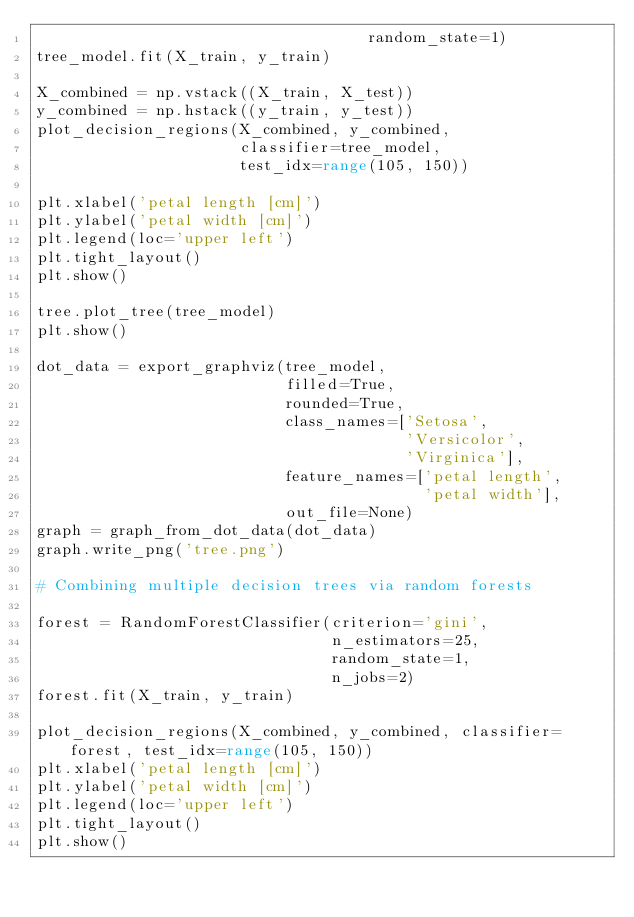Convert code to text. <code><loc_0><loc_0><loc_500><loc_500><_Python_>                                    random_state=1)
tree_model.fit(X_train, y_train)

X_combined = np.vstack((X_train, X_test))
y_combined = np.hstack((y_train, y_test))
plot_decision_regions(X_combined, y_combined, 
                      classifier=tree_model,
                      test_idx=range(105, 150))

plt.xlabel('petal length [cm]')
plt.ylabel('petal width [cm]')
plt.legend(loc='upper left')
plt.tight_layout()
plt.show()

tree.plot_tree(tree_model)
plt.show()

dot_data = export_graphviz(tree_model,
                           filled=True, 
                           rounded=True,
                           class_names=['Setosa', 
                                        'Versicolor',
                                        'Virginica'],
                           feature_names=['petal length', 
                                          'petal width'],
                           out_file=None) 
graph = graph_from_dot_data(dot_data) 
graph.write_png('tree.png')

# Combining multiple decision trees via random forests

forest = RandomForestClassifier(criterion='gini',
                                n_estimators=25, 
                                random_state=1,
                                n_jobs=2)
forest.fit(X_train, y_train)

plot_decision_regions(X_combined, y_combined, classifier=forest, test_idx=range(105, 150))
plt.xlabel('petal length [cm]')
plt.ylabel('petal width [cm]')
plt.legend(loc='upper left')
plt.tight_layout()
plt.show()</code> 